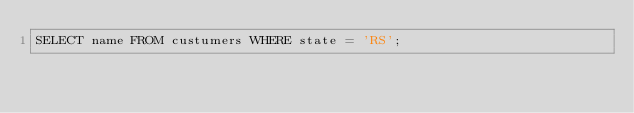Convert code to text. <code><loc_0><loc_0><loc_500><loc_500><_SQL_>SELECT name FROM custumers WHERE state = 'RS';
</code> 